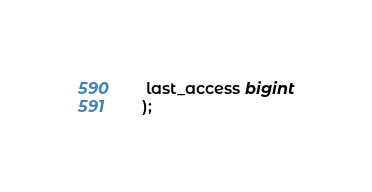<code> <loc_0><loc_0><loc_500><loc_500><_SQL_> last_access bigint
);
</code> 